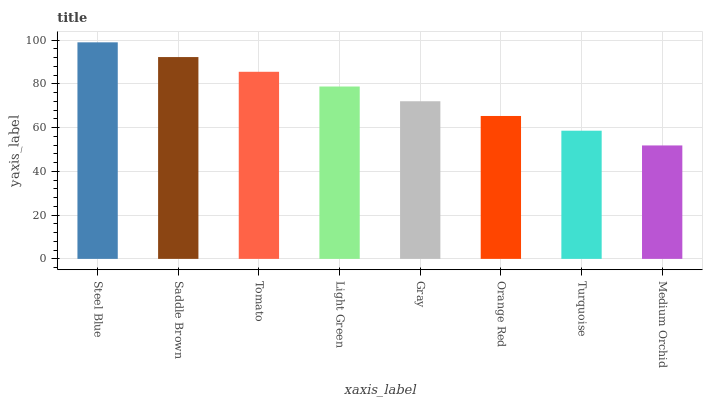Is Medium Orchid the minimum?
Answer yes or no. Yes. Is Steel Blue the maximum?
Answer yes or no. Yes. Is Saddle Brown the minimum?
Answer yes or no. No. Is Saddle Brown the maximum?
Answer yes or no. No. Is Steel Blue greater than Saddle Brown?
Answer yes or no. Yes. Is Saddle Brown less than Steel Blue?
Answer yes or no. Yes. Is Saddle Brown greater than Steel Blue?
Answer yes or no. No. Is Steel Blue less than Saddle Brown?
Answer yes or no. No. Is Light Green the high median?
Answer yes or no. Yes. Is Gray the low median?
Answer yes or no. Yes. Is Steel Blue the high median?
Answer yes or no. No. Is Saddle Brown the low median?
Answer yes or no. No. 